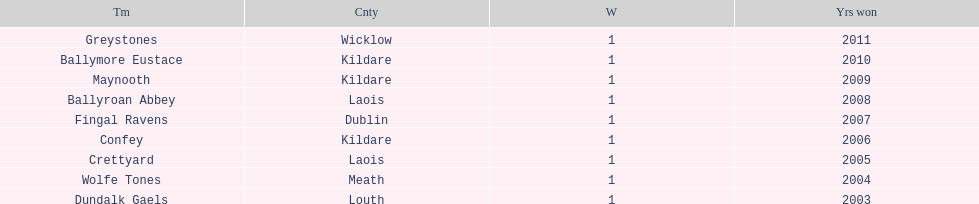What is the years won for each team 2011, 2010, 2009, 2008, 2007, 2006, 2005, 2004, 2003. 